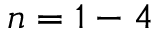Convert formula to latex. <formula><loc_0><loc_0><loc_500><loc_500>n = 1 - 4</formula> 